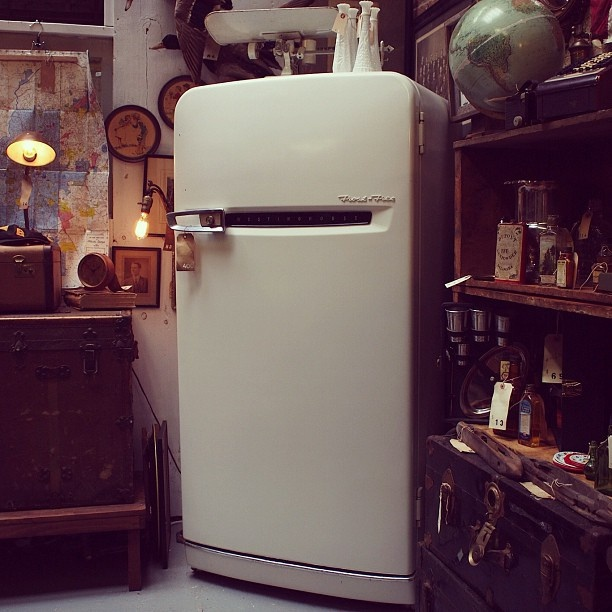Describe the objects in this image and their specific colors. I can see refrigerator in black, darkgray, lightgray, and gray tones, suitcase in black, maroon, brown, and tan tones, bottle in black, maroon, gray, and brown tones, bottle in black, maroon, brown, and gray tones, and bottle in black, maroon, and purple tones in this image. 